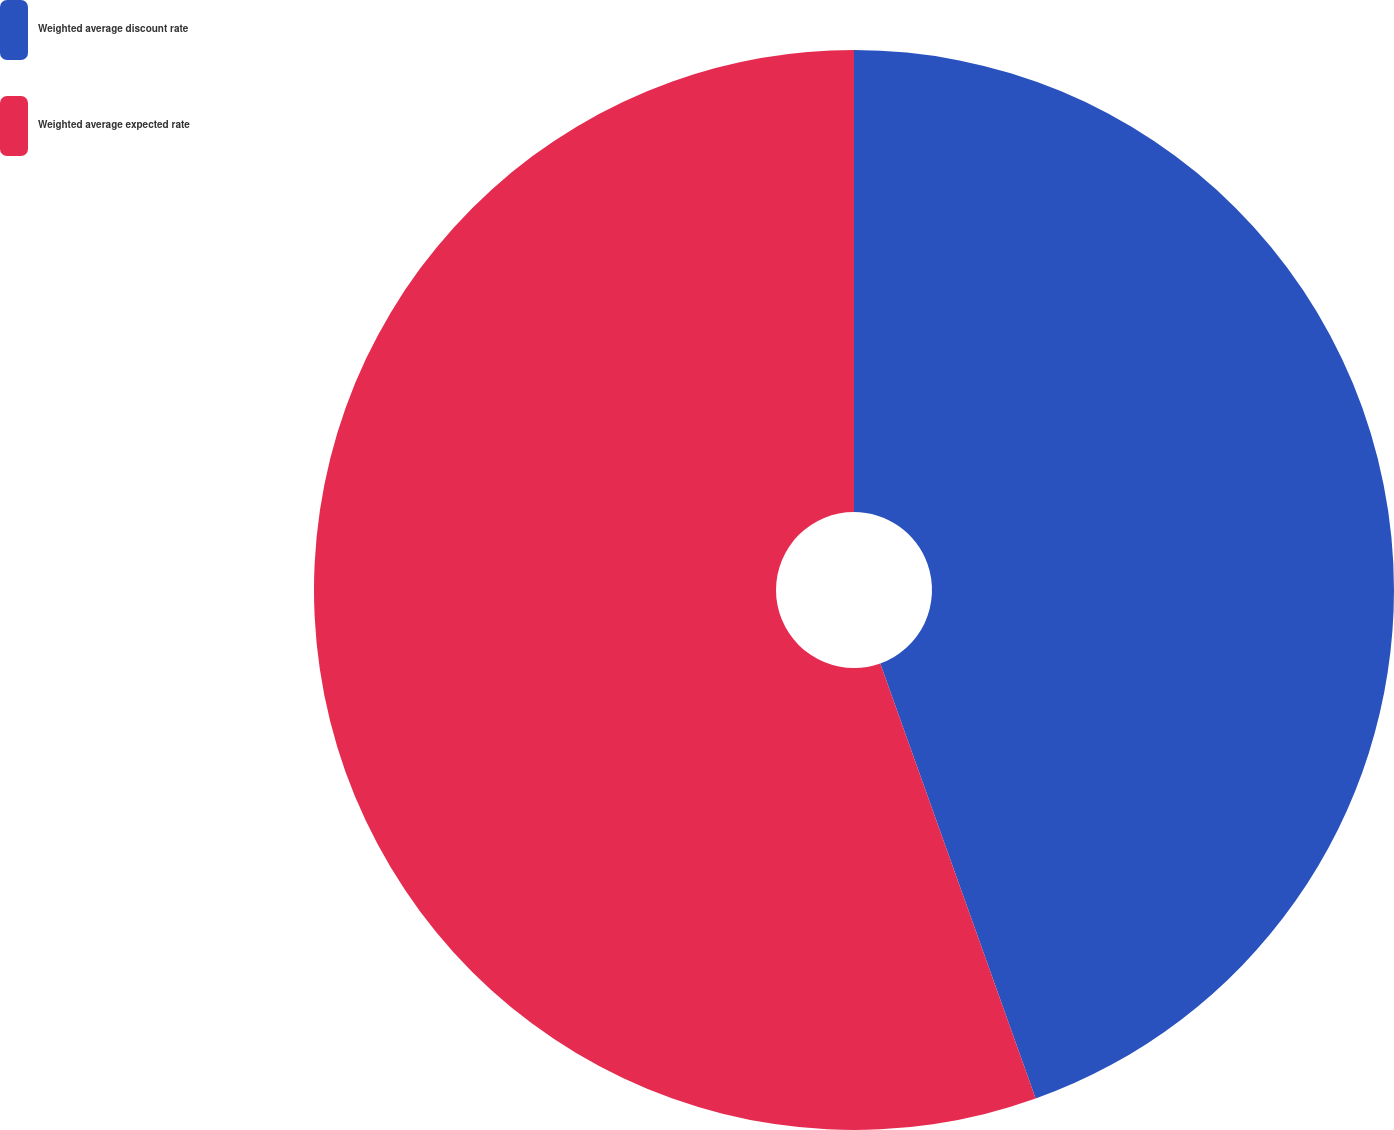Convert chart. <chart><loc_0><loc_0><loc_500><loc_500><pie_chart><fcel>Weighted average discount rate<fcel>Weighted average expected rate<nl><fcel>44.54%<fcel>55.46%<nl></chart> 